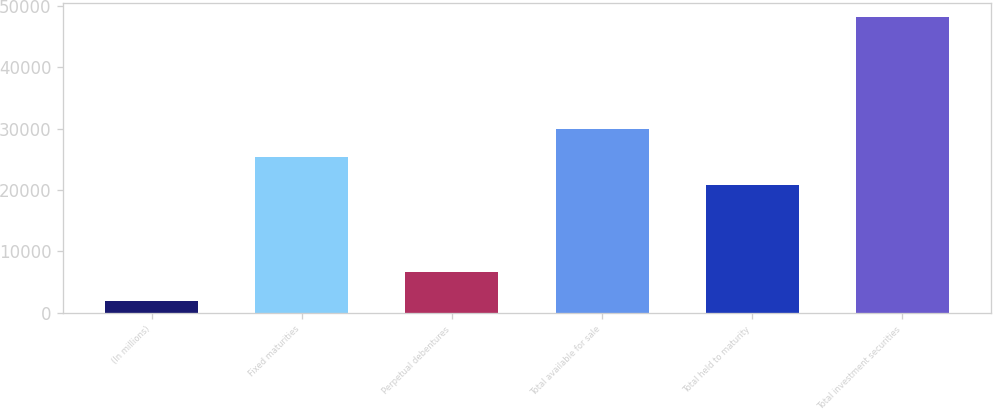Convert chart. <chart><loc_0><loc_0><loc_500><loc_500><bar_chart><fcel>(In millions)<fcel>Fixed maturities<fcel>Perpetual debentures<fcel>Total available for sale<fcel>Total held to maturity<fcel>Total investment securities<nl><fcel>2007<fcel>25393.5<fcel>6616.5<fcel>30003<fcel>20784<fcel>48102<nl></chart> 